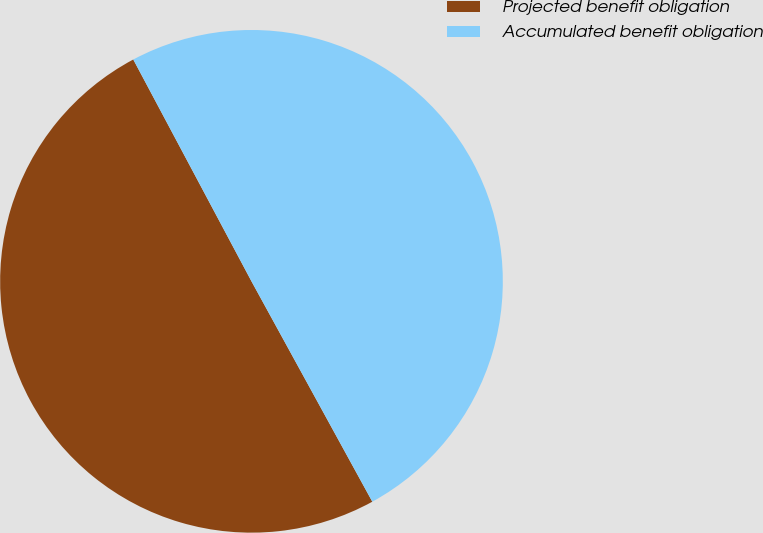Convert chart to OTSL. <chart><loc_0><loc_0><loc_500><loc_500><pie_chart><fcel>Projected benefit obligation<fcel>Accumulated benefit obligation<nl><fcel>50.19%<fcel>49.81%<nl></chart> 